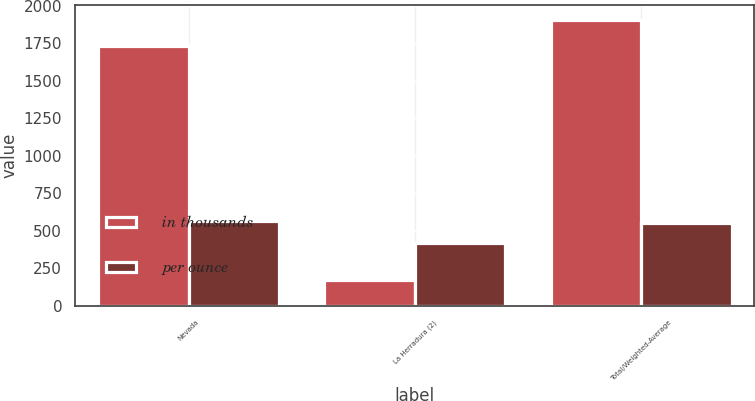<chart> <loc_0><loc_0><loc_500><loc_500><stacked_bar_chart><ecel><fcel>Nevada<fcel>La Herradura (2)<fcel>Total/Weighted-Average<nl><fcel>in thousands<fcel>1735<fcel>174<fcel>1909<nl><fcel>per ounce<fcel>565<fcel>420<fcel>551<nl></chart> 